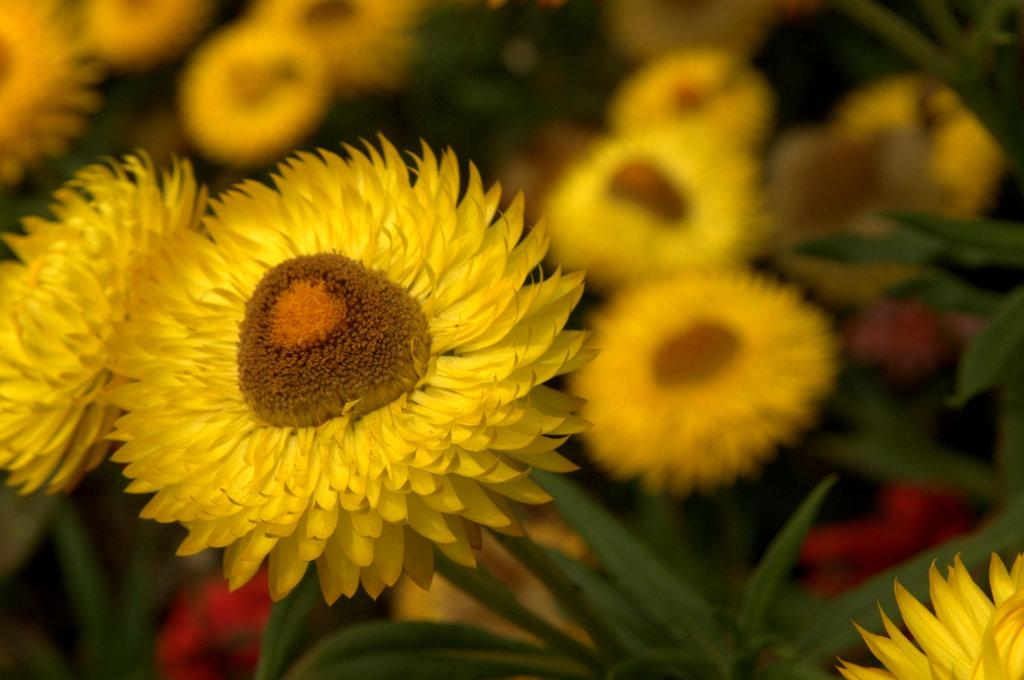What is present in the image? There are flowers in the image. What are the flowers situated on? The flowers are on plants. What colors can be seen on the flowers? The flowers have yellow, brown, and red colors. Can you describe the background of the image? The background of the image is blurred. Where is the toad being held in the image? There is no toad present in the image. What type of jail can be seen in the image? There is no jail present in the image. 